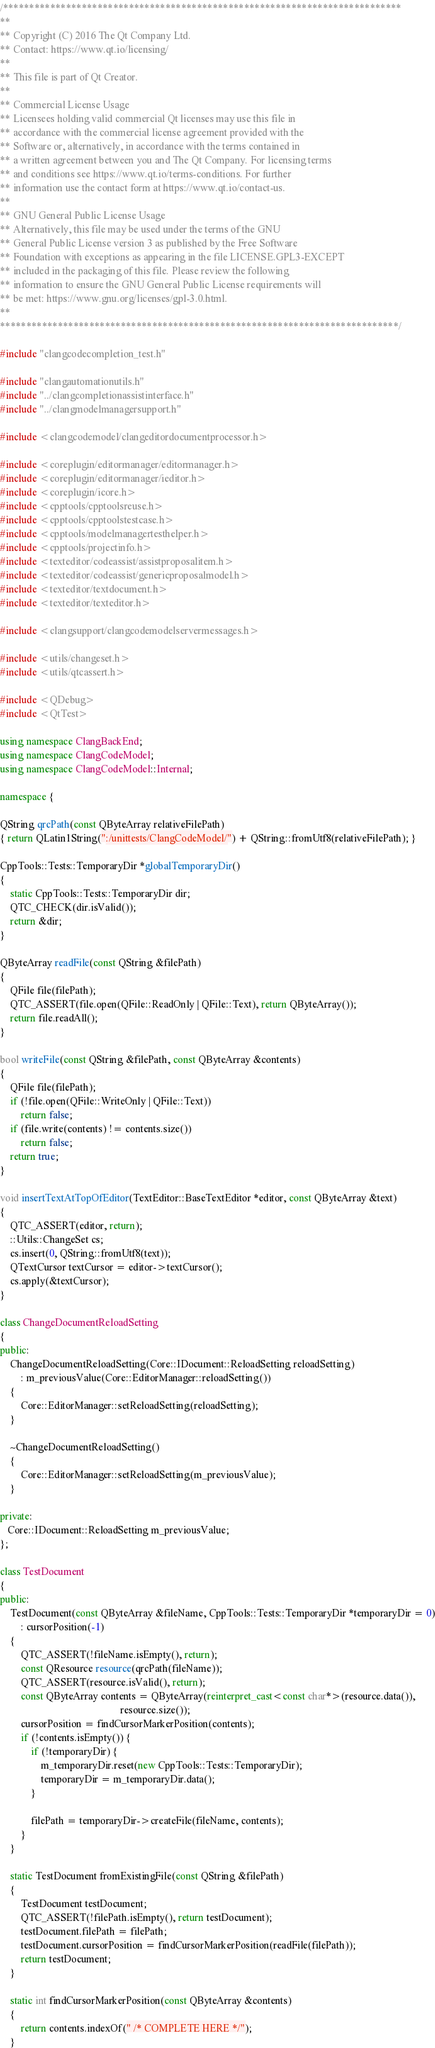Convert code to text. <code><loc_0><loc_0><loc_500><loc_500><_C++_>/****************************************************************************
**
** Copyright (C) 2016 The Qt Company Ltd.
** Contact: https://www.qt.io/licensing/
**
** This file is part of Qt Creator.
**
** Commercial License Usage
** Licensees holding valid commercial Qt licenses may use this file in
** accordance with the commercial license agreement provided with the
** Software or, alternatively, in accordance with the terms contained in
** a written agreement between you and The Qt Company. For licensing terms
** and conditions see https://www.qt.io/terms-conditions. For further
** information use the contact form at https://www.qt.io/contact-us.
**
** GNU General Public License Usage
** Alternatively, this file may be used under the terms of the GNU
** General Public License version 3 as published by the Free Software
** Foundation with exceptions as appearing in the file LICENSE.GPL3-EXCEPT
** included in the packaging of this file. Please review the following
** information to ensure the GNU General Public License requirements will
** be met: https://www.gnu.org/licenses/gpl-3.0.html.
**
****************************************************************************/

#include "clangcodecompletion_test.h"

#include "clangautomationutils.h"
#include "../clangcompletionassistinterface.h"
#include "../clangmodelmanagersupport.h"

#include <clangcodemodel/clangeditordocumentprocessor.h>

#include <coreplugin/editormanager/editormanager.h>
#include <coreplugin/editormanager/ieditor.h>
#include <coreplugin/icore.h>
#include <cpptools/cpptoolsreuse.h>
#include <cpptools/cpptoolstestcase.h>
#include <cpptools/modelmanagertesthelper.h>
#include <cpptools/projectinfo.h>
#include <texteditor/codeassist/assistproposalitem.h>
#include <texteditor/codeassist/genericproposalmodel.h>
#include <texteditor/textdocument.h>
#include <texteditor/texteditor.h>

#include <clangsupport/clangcodemodelservermessages.h>

#include <utils/changeset.h>
#include <utils/qtcassert.h>

#include <QDebug>
#include <QtTest>

using namespace ClangBackEnd;
using namespace ClangCodeModel;
using namespace ClangCodeModel::Internal;

namespace {

QString qrcPath(const QByteArray relativeFilePath)
{ return QLatin1String(":/unittests/ClangCodeModel/") + QString::fromUtf8(relativeFilePath); }

CppTools::Tests::TemporaryDir *globalTemporaryDir()
{
    static CppTools::Tests::TemporaryDir dir;
    QTC_CHECK(dir.isValid());
    return &dir;
}

QByteArray readFile(const QString &filePath)
{
    QFile file(filePath);
    QTC_ASSERT(file.open(QFile::ReadOnly | QFile::Text), return QByteArray());
    return file.readAll();
}

bool writeFile(const QString &filePath, const QByteArray &contents)
{
    QFile file(filePath);
    if (!file.open(QFile::WriteOnly | QFile::Text))
        return false;
    if (file.write(contents) != contents.size())
        return false;
    return true;
}

void insertTextAtTopOfEditor(TextEditor::BaseTextEditor *editor, const QByteArray &text)
{
    QTC_ASSERT(editor, return);
    ::Utils::ChangeSet cs;
    cs.insert(0, QString::fromUtf8(text));
    QTextCursor textCursor = editor->textCursor();
    cs.apply(&textCursor);
}

class ChangeDocumentReloadSetting
{
public:
    ChangeDocumentReloadSetting(Core::IDocument::ReloadSetting reloadSetting)
        : m_previousValue(Core::EditorManager::reloadSetting())
    {
        Core::EditorManager::setReloadSetting(reloadSetting);
    }

    ~ChangeDocumentReloadSetting()
    {
        Core::EditorManager::setReloadSetting(m_previousValue);
    }

private:
   Core::IDocument::ReloadSetting m_previousValue;
};

class TestDocument
{
public:
    TestDocument(const QByteArray &fileName, CppTools::Tests::TemporaryDir *temporaryDir = 0)
        : cursorPosition(-1)
    {
        QTC_ASSERT(!fileName.isEmpty(), return);
        const QResource resource(qrcPath(fileName));
        QTC_ASSERT(resource.isValid(), return);
        const QByteArray contents = QByteArray(reinterpret_cast<const char*>(resource.data()),
                                               resource.size());
        cursorPosition = findCursorMarkerPosition(contents);
        if (!contents.isEmpty()) {
            if (!temporaryDir) {
                m_temporaryDir.reset(new CppTools::Tests::TemporaryDir);
                temporaryDir = m_temporaryDir.data();
            }

            filePath = temporaryDir->createFile(fileName, contents);
        }
    }

    static TestDocument fromExistingFile(const QString &filePath)
    {
        TestDocument testDocument;
        QTC_ASSERT(!filePath.isEmpty(), return testDocument);
        testDocument.filePath = filePath;
        testDocument.cursorPosition = findCursorMarkerPosition(readFile(filePath));
        return testDocument;
    }

    static int findCursorMarkerPosition(const QByteArray &contents)
    {
        return contents.indexOf(" /* COMPLETE HERE */");
    }
</code> 